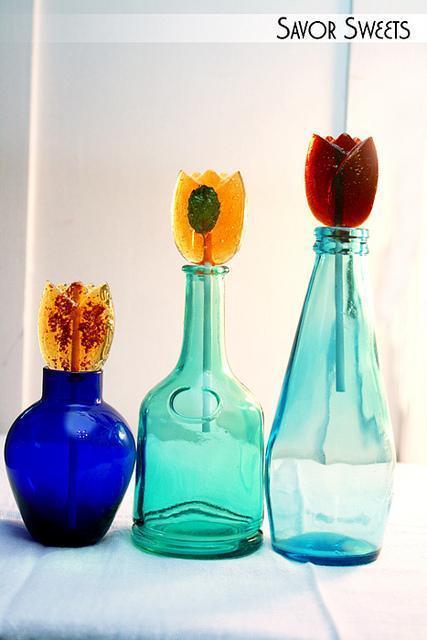How many vases are there?
Give a very brief answer. 3. How many dining tables are there?
Give a very brief answer. 1. 